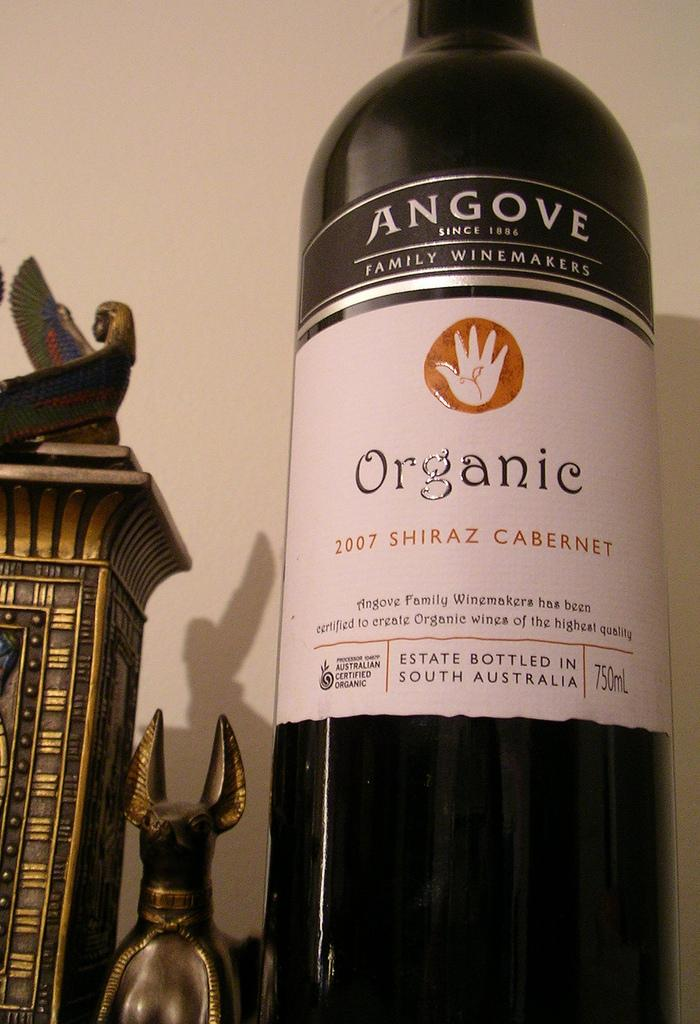<image>
Render a clear and concise summary of the photo. Bottle of organic wine that is shiraz cabinet 